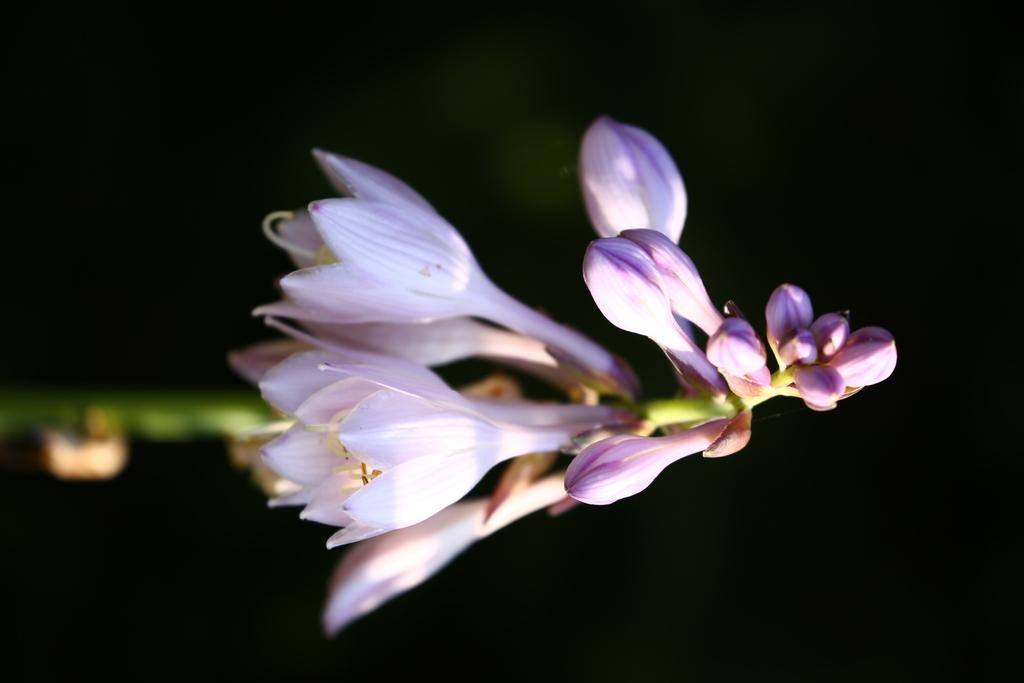What type of plants can be seen in the image? There are flowers in the image. Can you describe the stage of growth for the flowers? There are buds on the stem of a plant in the image. What type of joke is being told by the flowers in the image? There is no indication of a joke being told in the image; it features flowers and buds on a stem. 